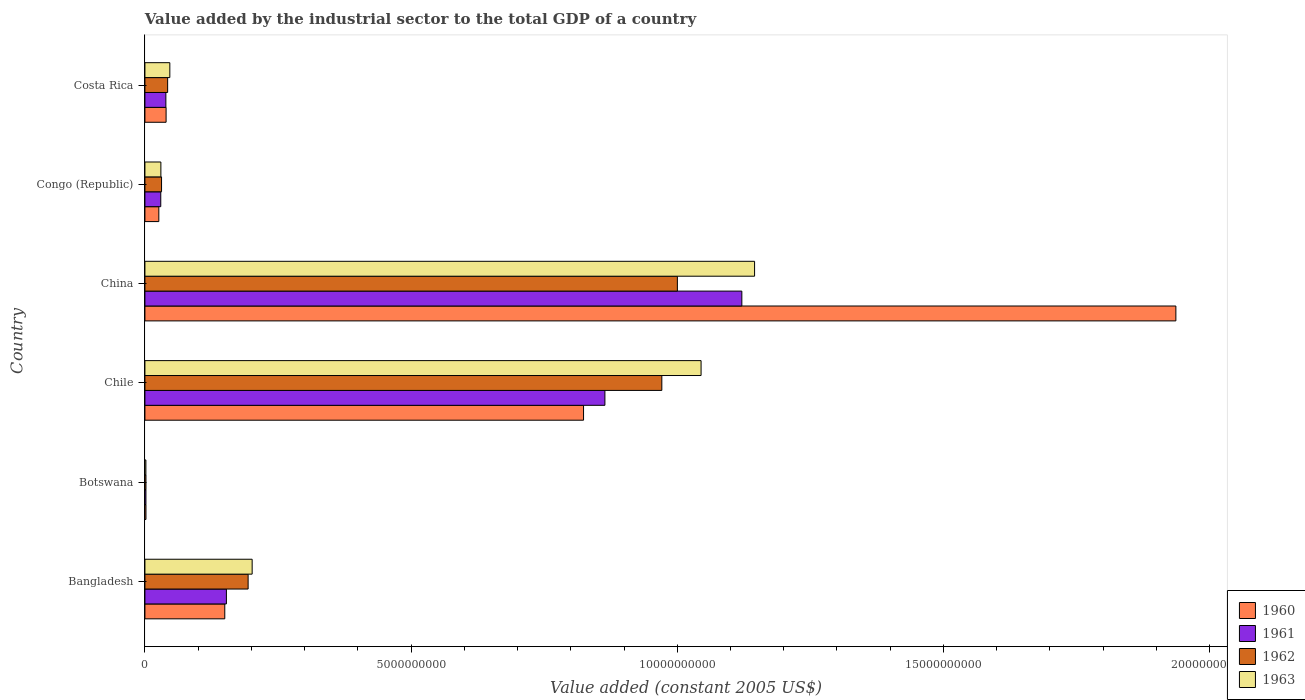Are the number of bars per tick equal to the number of legend labels?
Offer a terse response. Yes. What is the label of the 2nd group of bars from the top?
Your answer should be compact. Congo (Republic). In how many cases, is the number of bars for a given country not equal to the number of legend labels?
Ensure brevity in your answer.  0. What is the value added by the industrial sector in 1963 in Bangladesh?
Your answer should be very brief. 2.01e+09. Across all countries, what is the maximum value added by the industrial sector in 1963?
Offer a very short reply. 1.15e+1. Across all countries, what is the minimum value added by the industrial sector in 1960?
Offer a very short reply. 1.96e+07. In which country was the value added by the industrial sector in 1960 maximum?
Keep it short and to the point. China. In which country was the value added by the industrial sector in 1960 minimum?
Offer a terse response. Botswana. What is the total value added by the industrial sector in 1962 in the graph?
Your answer should be very brief. 2.24e+1. What is the difference between the value added by the industrial sector in 1963 in Botswana and that in Costa Rica?
Offer a terse response. -4.50e+08. What is the difference between the value added by the industrial sector in 1962 in Botswana and the value added by the industrial sector in 1963 in Congo (Republic)?
Your response must be concise. -2.80e+08. What is the average value added by the industrial sector in 1960 per country?
Offer a very short reply. 4.96e+09. What is the difference between the value added by the industrial sector in 1960 and value added by the industrial sector in 1961 in China?
Keep it short and to the point. 8.15e+09. In how many countries, is the value added by the industrial sector in 1961 greater than 3000000000 US$?
Ensure brevity in your answer.  2. What is the ratio of the value added by the industrial sector in 1960 in Bangladesh to that in Chile?
Provide a short and direct response. 0.18. Is the value added by the industrial sector in 1963 in Botswana less than that in Costa Rica?
Make the answer very short. Yes. What is the difference between the highest and the second highest value added by the industrial sector in 1960?
Provide a succinct answer. 1.11e+1. What is the difference between the highest and the lowest value added by the industrial sector in 1961?
Provide a short and direct response. 1.12e+1. Is the sum of the value added by the industrial sector in 1960 in China and Congo (Republic) greater than the maximum value added by the industrial sector in 1963 across all countries?
Offer a very short reply. Yes. How many bars are there?
Ensure brevity in your answer.  24. Are the values on the major ticks of X-axis written in scientific E-notation?
Offer a very short reply. No. Does the graph contain any zero values?
Keep it short and to the point. No. Does the graph contain grids?
Offer a terse response. No. Where does the legend appear in the graph?
Your answer should be very brief. Bottom right. How many legend labels are there?
Keep it short and to the point. 4. How are the legend labels stacked?
Provide a succinct answer. Vertical. What is the title of the graph?
Offer a very short reply. Value added by the industrial sector to the total GDP of a country. Does "1998" appear as one of the legend labels in the graph?
Make the answer very short. No. What is the label or title of the X-axis?
Make the answer very short. Value added (constant 2005 US$). What is the label or title of the Y-axis?
Your response must be concise. Country. What is the Value added (constant 2005 US$) of 1960 in Bangladesh?
Offer a terse response. 1.50e+09. What is the Value added (constant 2005 US$) of 1961 in Bangladesh?
Offer a very short reply. 1.53e+09. What is the Value added (constant 2005 US$) in 1962 in Bangladesh?
Keep it short and to the point. 1.94e+09. What is the Value added (constant 2005 US$) of 1963 in Bangladesh?
Ensure brevity in your answer.  2.01e+09. What is the Value added (constant 2005 US$) of 1960 in Botswana?
Make the answer very short. 1.96e+07. What is the Value added (constant 2005 US$) of 1961 in Botswana?
Your response must be concise. 1.92e+07. What is the Value added (constant 2005 US$) of 1962 in Botswana?
Provide a short and direct response. 1.98e+07. What is the Value added (constant 2005 US$) of 1963 in Botswana?
Make the answer very short. 1.83e+07. What is the Value added (constant 2005 US$) of 1960 in Chile?
Make the answer very short. 8.24e+09. What is the Value added (constant 2005 US$) in 1961 in Chile?
Your answer should be compact. 8.64e+09. What is the Value added (constant 2005 US$) in 1962 in Chile?
Your response must be concise. 9.71e+09. What is the Value added (constant 2005 US$) of 1963 in Chile?
Your answer should be compact. 1.04e+1. What is the Value added (constant 2005 US$) of 1960 in China?
Make the answer very short. 1.94e+1. What is the Value added (constant 2005 US$) of 1961 in China?
Your answer should be compact. 1.12e+1. What is the Value added (constant 2005 US$) of 1962 in China?
Provide a succinct answer. 1.00e+1. What is the Value added (constant 2005 US$) of 1963 in China?
Offer a very short reply. 1.15e+1. What is the Value added (constant 2005 US$) of 1960 in Congo (Republic)?
Ensure brevity in your answer.  2.61e+08. What is the Value added (constant 2005 US$) in 1961 in Congo (Republic)?
Give a very brief answer. 2.98e+08. What is the Value added (constant 2005 US$) in 1962 in Congo (Republic)?
Your answer should be compact. 3.12e+08. What is the Value added (constant 2005 US$) in 1963 in Congo (Republic)?
Give a very brief answer. 3.00e+08. What is the Value added (constant 2005 US$) of 1960 in Costa Rica?
Ensure brevity in your answer.  3.98e+08. What is the Value added (constant 2005 US$) in 1961 in Costa Rica?
Provide a succinct answer. 3.94e+08. What is the Value added (constant 2005 US$) of 1962 in Costa Rica?
Provide a short and direct response. 4.27e+08. What is the Value added (constant 2005 US$) of 1963 in Costa Rica?
Provide a succinct answer. 4.68e+08. Across all countries, what is the maximum Value added (constant 2005 US$) in 1960?
Provide a short and direct response. 1.94e+1. Across all countries, what is the maximum Value added (constant 2005 US$) in 1961?
Give a very brief answer. 1.12e+1. Across all countries, what is the maximum Value added (constant 2005 US$) in 1962?
Give a very brief answer. 1.00e+1. Across all countries, what is the maximum Value added (constant 2005 US$) of 1963?
Your response must be concise. 1.15e+1. Across all countries, what is the minimum Value added (constant 2005 US$) in 1960?
Provide a short and direct response. 1.96e+07. Across all countries, what is the minimum Value added (constant 2005 US$) in 1961?
Offer a very short reply. 1.92e+07. Across all countries, what is the minimum Value added (constant 2005 US$) in 1962?
Your answer should be very brief. 1.98e+07. Across all countries, what is the minimum Value added (constant 2005 US$) of 1963?
Ensure brevity in your answer.  1.83e+07. What is the total Value added (constant 2005 US$) of 1960 in the graph?
Your response must be concise. 2.98e+1. What is the total Value added (constant 2005 US$) of 1961 in the graph?
Your answer should be compact. 2.21e+1. What is the total Value added (constant 2005 US$) in 1962 in the graph?
Ensure brevity in your answer.  2.24e+1. What is the total Value added (constant 2005 US$) in 1963 in the graph?
Your answer should be compact. 2.47e+1. What is the difference between the Value added (constant 2005 US$) of 1960 in Bangladesh and that in Botswana?
Your response must be concise. 1.48e+09. What is the difference between the Value added (constant 2005 US$) in 1961 in Bangladesh and that in Botswana?
Make the answer very short. 1.51e+09. What is the difference between the Value added (constant 2005 US$) of 1962 in Bangladesh and that in Botswana?
Your answer should be compact. 1.92e+09. What is the difference between the Value added (constant 2005 US$) of 1963 in Bangladesh and that in Botswana?
Provide a succinct answer. 2.00e+09. What is the difference between the Value added (constant 2005 US$) of 1960 in Bangladesh and that in Chile?
Make the answer very short. -6.74e+09. What is the difference between the Value added (constant 2005 US$) in 1961 in Bangladesh and that in Chile?
Provide a short and direct response. -7.11e+09. What is the difference between the Value added (constant 2005 US$) in 1962 in Bangladesh and that in Chile?
Provide a short and direct response. -7.77e+09. What is the difference between the Value added (constant 2005 US$) in 1963 in Bangladesh and that in Chile?
Offer a very short reply. -8.43e+09. What is the difference between the Value added (constant 2005 US$) in 1960 in Bangladesh and that in China?
Your answer should be very brief. -1.79e+1. What is the difference between the Value added (constant 2005 US$) of 1961 in Bangladesh and that in China?
Your response must be concise. -9.68e+09. What is the difference between the Value added (constant 2005 US$) in 1962 in Bangladesh and that in China?
Offer a terse response. -8.06e+09. What is the difference between the Value added (constant 2005 US$) in 1963 in Bangladesh and that in China?
Your answer should be very brief. -9.44e+09. What is the difference between the Value added (constant 2005 US$) in 1960 in Bangladesh and that in Congo (Republic)?
Your answer should be compact. 1.24e+09. What is the difference between the Value added (constant 2005 US$) in 1961 in Bangladesh and that in Congo (Republic)?
Your answer should be very brief. 1.23e+09. What is the difference between the Value added (constant 2005 US$) in 1962 in Bangladesh and that in Congo (Republic)?
Your response must be concise. 1.63e+09. What is the difference between the Value added (constant 2005 US$) of 1963 in Bangladesh and that in Congo (Republic)?
Ensure brevity in your answer.  1.71e+09. What is the difference between the Value added (constant 2005 US$) in 1960 in Bangladesh and that in Costa Rica?
Make the answer very short. 1.10e+09. What is the difference between the Value added (constant 2005 US$) of 1961 in Bangladesh and that in Costa Rica?
Give a very brief answer. 1.14e+09. What is the difference between the Value added (constant 2005 US$) in 1962 in Bangladesh and that in Costa Rica?
Keep it short and to the point. 1.51e+09. What is the difference between the Value added (constant 2005 US$) of 1963 in Bangladesh and that in Costa Rica?
Offer a very short reply. 1.55e+09. What is the difference between the Value added (constant 2005 US$) of 1960 in Botswana and that in Chile?
Provide a short and direct response. -8.22e+09. What is the difference between the Value added (constant 2005 US$) in 1961 in Botswana and that in Chile?
Provide a short and direct response. -8.62e+09. What is the difference between the Value added (constant 2005 US$) in 1962 in Botswana and that in Chile?
Give a very brief answer. -9.69e+09. What is the difference between the Value added (constant 2005 US$) of 1963 in Botswana and that in Chile?
Keep it short and to the point. -1.04e+1. What is the difference between the Value added (constant 2005 US$) of 1960 in Botswana and that in China?
Your answer should be very brief. -1.93e+1. What is the difference between the Value added (constant 2005 US$) in 1961 in Botswana and that in China?
Your response must be concise. -1.12e+1. What is the difference between the Value added (constant 2005 US$) in 1962 in Botswana and that in China?
Your response must be concise. -9.98e+09. What is the difference between the Value added (constant 2005 US$) in 1963 in Botswana and that in China?
Your answer should be very brief. -1.14e+1. What is the difference between the Value added (constant 2005 US$) in 1960 in Botswana and that in Congo (Republic)?
Provide a succinct answer. -2.42e+08. What is the difference between the Value added (constant 2005 US$) of 1961 in Botswana and that in Congo (Republic)?
Provide a short and direct response. -2.78e+08. What is the difference between the Value added (constant 2005 US$) of 1962 in Botswana and that in Congo (Republic)?
Provide a short and direct response. -2.93e+08. What is the difference between the Value added (constant 2005 US$) in 1963 in Botswana and that in Congo (Republic)?
Offer a very short reply. -2.81e+08. What is the difference between the Value added (constant 2005 US$) in 1960 in Botswana and that in Costa Rica?
Provide a succinct answer. -3.78e+08. What is the difference between the Value added (constant 2005 US$) of 1961 in Botswana and that in Costa Rica?
Offer a terse response. -3.74e+08. What is the difference between the Value added (constant 2005 US$) in 1962 in Botswana and that in Costa Rica?
Make the answer very short. -4.07e+08. What is the difference between the Value added (constant 2005 US$) of 1963 in Botswana and that in Costa Rica?
Offer a terse response. -4.50e+08. What is the difference between the Value added (constant 2005 US$) in 1960 in Chile and that in China?
Give a very brief answer. -1.11e+1. What is the difference between the Value added (constant 2005 US$) in 1961 in Chile and that in China?
Keep it short and to the point. -2.57e+09. What is the difference between the Value added (constant 2005 US$) of 1962 in Chile and that in China?
Provide a short and direct response. -2.92e+08. What is the difference between the Value added (constant 2005 US$) of 1963 in Chile and that in China?
Keep it short and to the point. -1.01e+09. What is the difference between the Value added (constant 2005 US$) of 1960 in Chile and that in Congo (Republic)?
Provide a short and direct response. 7.98e+09. What is the difference between the Value added (constant 2005 US$) in 1961 in Chile and that in Congo (Republic)?
Make the answer very short. 8.34e+09. What is the difference between the Value added (constant 2005 US$) in 1962 in Chile and that in Congo (Republic)?
Offer a very short reply. 9.40e+09. What is the difference between the Value added (constant 2005 US$) in 1963 in Chile and that in Congo (Republic)?
Provide a short and direct response. 1.01e+1. What is the difference between the Value added (constant 2005 US$) in 1960 in Chile and that in Costa Rica?
Provide a short and direct response. 7.84e+09. What is the difference between the Value added (constant 2005 US$) in 1961 in Chile and that in Costa Rica?
Offer a terse response. 8.25e+09. What is the difference between the Value added (constant 2005 US$) of 1962 in Chile and that in Costa Rica?
Your answer should be very brief. 9.28e+09. What is the difference between the Value added (constant 2005 US$) in 1963 in Chile and that in Costa Rica?
Your answer should be compact. 9.98e+09. What is the difference between the Value added (constant 2005 US$) in 1960 in China and that in Congo (Republic)?
Your answer should be compact. 1.91e+1. What is the difference between the Value added (constant 2005 US$) in 1961 in China and that in Congo (Republic)?
Your answer should be compact. 1.09e+1. What is the difference between the Value added (constant 2005 US$) in 1962 in China and that in Congo (Republic)?
Offer a terse response. 9.69e+09. What is the difference between the Value added (constant 2005 US$) of 1963 in China and that in Congo (Republic)?
Offer a very short reply. 1.12e+1. What is the difference between the Value added (constant 2005 US$) of 1960 in China and that in Costa Rica?
Offer a very short reply. 1.90e+1. What is the difference between the Value added (constant 2005 US$) of 1961 in China and that in Costa Rica?
Your answer should be compact. 1.08e+1. What is the difference between the Value added (constant 2005 US$) of 1962 in China and that in Costa Rica?
Your answer should be very brief. 9.58e+09. What is the difference between the Value added (constant 2005 US$) in 1963 in China and that in Costa Rica?
Your answer should be very brief. 1.10e+1. What is the difference between the Value added (constant 2005 US$) of 1960 in Congo (Republic) and that in Costa Rica?
Make the answer very short. -1.36e+08. What is the difference between the Value added (constant 2005 US$) of 1961 in Congo (Republic) and that in Costa Rica?
Your answer should be very brief. -9.59e+07. What is the difference between the Value added (constant 2005 US$) of 1962 in Congo (Republic) and that in Costa Rica?
Provide a succinct answer. -1.14e+08. What is the difference between the Value added (constant 2005 US$) of 1963 in Congo (Republic) and that in Costa Rica?
Make the answer very short. -1.68e+08. What is the difference between the Value added (constant 2005 US$) in 1960 in Bangladesh and the Value added (constant 2005 US$) in 1961 in Botswana?
Give a very brief answer. 1.48e+09. What is the difference between the Value added (constant 2005 US$) in 1960 in Bangladesh and the Value added (constant 2005 US$) in 1962 in Botswana?
Your answer should be very brief. 1.48e+09. What is the difference between the Value added (constant 2005 US$) of 1960 in Bangladesh and the Value added (constant 2005 US$) of 1963 in Botswana?
Your answer should be very brief. 1.48e+09. What is the difference between the Value added (constant 2005 US$) of 1961 in Bangladesh and the Value added (constant 2005 US$) of 1962 in Botswana?
Ensure brevity in your answer.  1.51e+09. What is the difference between the Value added (constant 2005 US$) of 1961 in Bangladesh and the Value added (constant 2005 US$) of 1963 in Botswana?
Provide a succinct answer. 1.51e+09. What is the difference between the Value added (constant 2005 US$) in 1962 in Bangladesh and the Value added (constant 2005 US$) in 1963 in Botswana?
Offer a terse response. 1.92e+09. What is the difference between the Value added (constant 2005 US$) in 1960 in Bangladesh and the Value added (constant 2005 US$) in 1961 in Chile?
Offer a very short reply. -7.14e+09. What is the difference between the Value added (constant 2005 US$) of 1960 in Bangladesh and the Value added (constant 2005 US$) of 1962 in Chile?
Offer a very short reply. -8.21e+09. What is the difference between the Value added (constant 2005 US$) in 1960 in Bangladesh and the Value added (constant 2005 US$) in 1963 in Chile?
Keep it short and to the point. -8.95e+09. What is the difference between the Value added (constant 2005 US$) in 1961 in Bangladesh and the Value added (constant 2005 US$) in 1962 in Chile?
Give a very brief answer. -8.18e+09. What is the difference between the Value added (constant 2005 US$) of 1961 in Bangladesh and the Value added (constant 2005 US$) of 1963 in Chile?
Ensure brevity in your answer.  -8.92e+09. What is the difference between the Value added (constant 2005 US$) in 1962 in Bangladesh and the Value added (constant 2005 US$) in 1963 in Chile?
Give a very brief answer. -8.51e+09. What is the difference between the Value added (constant 2005 US$) in 1960 in Bangladesh and the Value added (constant 2005 US$) in 1961 in China?
Provide a short and direct response. -9.71e+09. What is the difference between the Value added (constant 2005 US$) in 1960 in Bangladesh and the Value added (constant 2005 US$) in 1962 in China?
Your answer should be compact. -8.50e+09. What is the difference between the Value added (constant 2005 US$) in 1960 in Bangladesh and the Value added (constant 2005 US$) in 1963 in China?
Your answer should be very brief. -9.95e+09. What is the difference between the Value added (constant 2005 US$) of 1961 in Bangladesh and the Value added (constant 2005 US$) of 1962 in China?
Your answer should be very brief. -8.47e+09. What is the difference between the Value added (constant 2005 US$) in 1961 in Bangladesh and the Value added (constant 2005 US$) in 1963 in China?
Your response must be concise. -9.92e+09. What is the difference between the Value added (constant 2005 US$) in 1962 in Bangladesh and the Value added (constant 2005 US$) in 1963 in China?
Provide a succinct answer. -9.51e+09. What is the difference between the Value added (constant 2005 US$) in 1960 in Bangladesh and the Value added (constant 2005 US$) in 1961 in Congo (Republic)?
Keep it short and to the point. 1.20e+09. What is the difference between the Value added (constant 2005 US$) of 1960 in Bangladesh and the Value added (constant 2005 US$) of 1962 in Congo (Republic)?
Your answer should be very brief. 1.19e+09. What is the difference between the Value added (constant 2005 US$) in 1960 in Bangladesh and the Value added (constant 2005 US$) in 1963 in Congo (Republic)?
Give a very brief answer. 1.20e+09. What is the difference between the Value added (constant 2005 US$) of 1961 in Bangladesh and the Value added (constant 2005 US$) of 1962 in Congo (Republic)?
Give a very brief answer. 1.22e+09. What is the difference between the Value added (constant 2005 US$) in 1961 in Bangladesh and the Value added (constant 2005 US$) in 1963 in Congo (Republic)?
Provide a succinct answer. 1.23e+09. What is the difference between the Value added (constant 2005 US$) of 1962 in Bangladesh and the Value added (constant 2005 US$) of 1963 in Congo (Republic)?
Provide a short and direct response. 1.64e+09. What is the difference between the Value added (constant 2005 US$) in 1960 in Bangladesh and the Value added (constant 2005 US$) in 1961 in Costa Rica?
Keep it short and to the point. 1.11e+09. What is the difference between the Value added (constant 2005 US$) of 1960 in Bangladesh and the Value added (constant 2005 US$) of 1962 in Costa Rica?
Offer a terse response. 1.07e+09. What is the difference between the Value added (constant 2005 US$) in 1960 in Bangladesh and the Value added (constant 2005 US$) in 1963 in Costa Rica?
Your answer should be very brief. 1.03e+09. What is the difference between the Value added (constant 2005 US$) in 1961 in Bangladesh and the Value added (constant 2005 US$) in 1962 in Costa Rica?
Make the answer very short. 1.10e+09. What is the difference between the Value added (constant 2005 US$) of 1961 in Bangladesh and the Value added (constant 2005 US$) of 1963 in Costa Rica?
Provide a succinct answer. 1.06e+09. What is the difference between the Value added (constant 2005 US$) in 1962 in Bangladesh and the Value added (constant 2005 US$) in 1963 in Costa Rica?
Provide a short and direct response. 1.47e+09. What is the difference between the Value added (constant 2005 US$) in 1960 in Botswana and the Value added (constant 2005 US$) in 1961 in Chile?
Ensure brevity in your answer.  -8.62e+09. What is the difference between the Value added (constant 2005 US$) in 1960 in Botswana and the Value added (constant 2005 US$) in 1962 in Chile?
Your answer should be very brief. -9.69e+09. What is the difference between the Value added (constant 2005 US$) in 1960 in Botswana and the Value added (constant 2005 US$) in 1963 in Chile?
Your response must be concise. -1.04e+1. What is the difference between the Value added (constant 2005 US$) in 1961 in Botswana and the Value added (constant 2005 US$) in 1962 in Chile?
Give a very brief answer. -9.69e+09. What is the difference between the Value added (constant 2005 US$) in 1961 in Botswana and the Value added (constant 2005 US$) in 1963 in Chile?
Your answer should be very brief. -1.04e+1. What is the difference between the Value added (constant 2005 US$) of 1962 in Botswana and the Value added (constant 2005 US$) of 1963 in Chile?
Ensure brevity in your answer.  -1.04e+1. What is the difference between the Value added (constant 2005 US$) in 1960 in Botswana and the Value added (constant 2005 US$) in 1961 in China?
Your answer should be very brief. -1.12e+1. What is the difference between the Value added (constant 2005 US$) of 1960 in Botswana and the Value added (constant 2005 US$) of 1962 in China?
Offer a very short reply. -9.98e+09. What is the difference between the Value added (constant 2005 US$) in 1960 in Botswana and the Value added (constant 2005 US$) in 1963 in China?
Keep it short and to the point. -1.14e+1. What is the difference between the Value added (constant 2005 US$) of 1961 in Botswana and the Value added (constant 2005 US$) of 1962 in China?
Provide a succinct answer. -9.98e+09. What is the difference between the Value added (constant 2005 US$) of 1961 in Botswana and the Value added (constant 2005 US$) of 1963 in China?
Your answer should be compact. -1.14e+1. What is the difference between the Value added (constant 2005 US$) in 1962 in Botswana and the Value added (constant 2005 US$) in 1963 in China?
Provide a succinct answer. -1.14e+1. What is the difference between the Value added (constant 2005 US$) in 1960 in Botswana and the Value added (constant 2005 US$) in 1961 in Congo (Republic)?
Offer a very short reply. -2.78e+08. What is the difference between the Value added (constant 2005 US$) in 1960 in Botswana and the Value added (constant 2005 US$) in 1962 in Congo (Republic)?
Your answer should be compact. -2.93e+08. What is the difference between the Value added (constant 2005 US$) of 1960 in Botswana and the Value added (constant 2005 US$) of 1963 in Congo (Republic)?
Offer a very short reply. -2.80e+08. What is the difference between the Value added (constant 2005 US$) in 1961 in Botswana and the Value added (constant 2005 US$) in 1962 in Congo (Republic)?
Make the answer very short. -2.93e+08. What is the difference between the Value added (constant 2005 US$) of 1961 in Botswana and the Value added (constant 2005 US$) of 1963 in Congo (Republic)?
Your response must be concise. -2.81e+08. What is the difference between the Value added (constant 2005 US$) in 1962 in Botswana and the Value added (constant 2005 US$) in 1963 in Congo (Republic)?
Your answer should be compact. -2.80e+08. What is the difference between the Value added (constant 2005 US$) of 1960 in Botswana and the Value added (constant 2005 US$) of 1961 in Costa Rica?
Make the answer very short. -3.74e+08. What is the difference between the Value added (constant 2005 US$) in 1960 in Botswana and the Value added (constant 2005 US$) in 1962 in Costa Rica?
Make the answer very short. -4.07e+08. What is the difference between the Value added (constant 2005 US$) in 1960 in Botswana and the Value added (constant 2005 US$) in 1963 in Costa Rica?
Provide a succinct answer. -4.48e+08. What is the difference between the Value added (constant 2005 US$) in 1961 in Botswana and the Value added (constant 2005 US$) in 1962 in Costa Rica?
Your answer should be very brief. -4.08e+08. What is the difference between the Value added (constant 2005 US$) of 1961 in Botswana and the Value added (constant 2005 US$) of 1963 in Costa Rica?
Offer a terse response. -4.49e+08. What is the difference between the Value added (constant 2005 US$) in 1962 in Botswana and the Value added (constant 2005 US$) in 1963 in Costa Rica?
Offer a terse response. -4.48e+08. What is the difference between the Value added (constant 2005 US$) of 1960 in Chile and the Value added (constant 2005 US$) of 1961 in China?
Keep it short and to the point. -2.97e+09. What is the difference between the Value added (constant 2005 US$) in 1960 in Chile and the Value added (constant 2005 US$) in 1962 in China?
Make the answer very short. -1.76e+09. What is the difference between the Value added (constant 2005 US$) in 1960 in Chile and the Value added (constant 2005 US$) in 1963 in China?
Offer a terse response. -3.21e+09. What is the difference between the Value added (constant 2005 US$) in 1961 in Chile and the Value added (constant 2005 US$) in 1962 in China?
Provide a succinct answer. -1.36e+09. What is the difference between the Value added (constant 2005 US$) of 1961 in Chile and the Value added (constant 2005 US$) of 1963 in China?
Your answer should be compact. -2.81e+09. What is the difference between the Value added (constant 2005 US$) in 1962 in Chile and the Value added (constant 2005 US$) in 1963 in China?
Your response must be concise. -1.74e+09. What is the difference between the Value added (constant 2005 US$) of 1960 in Chile and the Value added (constant 2005 US$) of 1961 in Congo (Republic)?
Give a very brief answer. 7.94e+09. What is the difference between the Value added (constant 2005 US$) in 1960 in Chile and the Value added (constant 2005 US$) in 1962 in Congo (Republic)?
Your response must be concise. 7.93e+09. What is the difference between the Value added (constant 2005 US$) of 1960 in Chile and the Value added (constant 2005 US$) of 1963 in Congo (Republic)?
Offer a very short reply. 7.94e+09. What is the difference between the Value added (constant 2005 US$) in 1961 in Chile and the Value added (constant 2005 US$) in 1962 in Congo (Republic)?
Provide a succinct answer. 8.33e+09. What is the difference between the Value added (constant 2005 US$) of 1961 in Chile and the Value added (constant 2005 US$) of 1963 in Congo (Republic)?
Make the answer very short. 8.34e+09. What is the difference between the Value added (constant 2005 US$) in 1962 in Chile and the Value added (constant 2005 US$) in 1963 in Congo (Republic)?
Keep it short and to the point. 9.41e+09. What is the difference between the Value added (constant 2005 US$) in 1960 in Chile and the Value added (constant 2005 US$) in 1961 in Costa Rica?
Keep it short and to the point. 7.85e+09. What is the difference between the Value added (constant 2005 US$) of 1960 in Chile and the Value added (constant 2005 US$) of 1962 in Costa Rica?
Give a very brief answer. 7.81e+09. What is the difference between the Value added (constant 2005 US$) in 1960 in Chile and the Value added (constant 2005 US$) in 1963 in Costa Rica?
Offer a very short reply. 7.77e+09. What is the difference between the Value added (constant 2005 US$) in 1961 in Chile and the Value added (constant 2005 US$) in 1962 in Costa Rica?
Offer a terse response. 8.21e+09. What is the difference between the Value added (constant 2005 US$) of 1961 in Chile and the Value added (constant 2005 US$) of 1963 in Costa Rica?
Your response must be concise. 8.17e+09. What is the difference between the Value added (constant 2005 US$) in 1962 in Chile and the Value added (constant 2005 US$) in 1963 in Costa Rica?
Ensure brevity in your answer.  9.24e+09. What is the difference between the Value added (constant 2005 US$) in 1960 in China and the Value added (constant 2005 US$) in 1961 in Congo (Republic)?
Offer a terse response. 1.91e+1. What is the difference between the Value added (constant 2005 US$) of 1960 in China and the Value added (constant 2005 US$) of 1962 in Congo (Republic)?
Provide a succinct answer. 1.91e+1. What is the difference between the Value added (constant 2005 US$) in 1960 in China and the Value added (constant 2005 US$) in 1963 in Congo (Republic)?
Offer a very short reply. 1.91e+1. What is the difference between the Value added (constant 2005 US$) in 1961 in China and the Value added (constant 2005 US$) in 1962 in Congo (Republic)?
Your answer should be compact. 1.09e+1. What is the difference between the Value added (constant 2005 US$) of 1961 in China and the Value added (constant 2005 US$) of 1963 in Congo (Republic)?
Your response must be concise. 1.09e+1. What is the difference between the Value added (constant 2005 US$) of 1962 in China and the Value added (constant 2005 US$) of 1963 in Congo (Republic)?
Offer a terse response. 9.70e+09. What is the difference between the Value added (constant 2005 US$) of 1960 in China and the Value added (constant 2005 US$) of 1961 in Costa Rica?
Your answer should be compact. 1.90e+1. What is the difference between the Value added (constant 2005 US$) in 1960 in China and the Value added (constant 2005 US$) in 1962 in Costa Rica?
Your answer should be compact. 1.89e+1. What is the difference between the Value added (constant 2005 US$) in 1960 in China and the Value added (constant 2005 US$) in 1963 in Costa Rica?
Keep it short and to the point. 1.89e+1. What is the difference between the Value added (constant 2005 US$) of 1961 in China and the Value added (constant 2005 US$) of 1962 in Costa Rica?
Offer a very short reply. 1.08e+1. What is the difference between the Value added (constant 2005 US$) of 1961 in China and the Value added (constant 2005 US$) of 1963 in Costa Rica?
Keep it short and to the point. 1.07e+1. What is the difference between the Value added (constant 2005 US$) of 1962 in China and the Value added (constant 2005 US$) of 1963 in Costa Rica?
Provide a succinct answer. 9.53e+09. What is the difference between the Value added (constant 2005 US$) in 1960 in Congo (Republic) and the Value added (constant 2005 US$) in 1961 in Costa Rica?
Offer a very short reply. -1.32e+08. What is the difference between the Value added (constant 2005 US$) of 1960 in Congo (Republic) and the Value added (constant 2005 US$) of 1962 in Costa Rica?
Your answer should be compact. -1.65e+08. What is the difference between the Value added (constant 2005 US$) in 1960 in Congo (Republic) and the Value added (constant 2005 US$) in 1963 in Costa Rica?
Offer a very short reply. -2.07e+08. What is the difference between the Value added (constant 2005 US$) of 1961 in Congo (Republic) and the Value added (constant 2005 US$) of 1962 in Costa Rica?
Your answer should be compact. -1.29e+08. What is the difference between the Value added (constant 2005 US$) in 1961 in Congo (Republic) and the Value added (constant 2005 US$) in 1963 in Costa Rica?
Offer a terse response. -1.70e+08. What is the difference between the Value added (constant 2005 US$) in 1962 in Congo (Republic) and the Value added (constant 2005 US$) in 1963 in Costa Rica?
Your answer should be compact. -1.56e+08. What is the average Value added (constant 2005 US$) of 1960 per country?
Offer a very short reply. 4.96e+09. What is the average Value added (constant 2005 US$) of 1961 per country?
Keep it short and to the point. 3.68e+09. What is the average Value added (constant 2005 US$) in 1962 per country?
Give a very brief answer. 3.74e+09. What is the average Value added (constant 2005 US$) in 1963 per country?
Provide a short and direct response. 4.12e+09. What is the difference between the Value added (constant 2005 US$) of 1960 and Value added (constant 2005 US$) of 1961 in Bangladesh?
Give a very brief answer. -3.05e+07. What is the difference between the Value added (constant 2005 US$) of 1960 and Value added (constant 2005 US$) of 1962 in Bangladesh?
Your answer should be compact. -4.38e+08. What is the difference between the Value added (constant 2005 US$) in 1960 and Value added (constant 2005 US$) in 1963 in Bangladesh?
Offer a terse response. -5.14e+08. What is the difference between the Value added (constant 2005 US$) in 1961 and Value added (constant 2005 US$) in 1962 in Bangladesh?
Your answer should be very brief. -4.08e+08. What is the difference between the Value added (constant 2005 US$) of 1961 and Value added (constant 2005 US$) of 1963 in Bangladesh?
Make the answer very short. -4.84e+08. What is the difference between the Value added (constant 2005 US$) in 1962 and Value added (constant 2005 US$) in 1963 in Bangladesh?
Make the answer very short. -7.60e+07. What is the difference between the Value added (constant 2005 US$) in 1960 and Value added (constant 2005 US$) in 1961 in Botswana?
Keep it short and to the point. 4.24e+05. What is the difference between the Value added (constant 2005 US$) of 1960 and Value added (constant 2005 US$) of 1962 in Botswana?
Provide a short and direct response. -2.12e+05. What is the difference between the Value added (constant 2005 US$) of 1960 and Value added (constant 2005 US$) of 1963 in Botswana?
Give a very brief answer. 1.27e+06. What is the difference between the Value added (constant 2005 US$) in 1961 and Value added (constant 2005 US$) in 1962 in Botswana?
Your answer should be very brief. -6.36e+05. What is the difference between the Value added (constant 2005 US$) of 1961 and Value added (constant 2005 US$) of 1963 in Botswana?
Give a very brief answer. 8.48e+05. What is the difference between the Value added (constant 2005 US$) in 1962 and Value added (constant 2005 US$) in 1963 in Botswana?
Your response must be concise. 1.48e+06. What is the difference between the Value added (constant 2005 US$) in 1960 and Value added (constant 2005 US$) in 1961 in Chile?
Your response must be concise. -4.01e+08. What is the difference between the Value added (constant 2005 US$) of 1960 and Value added (constant 2005 US$) of 1962 in Chile?
Make the answer very short. -1.47e+09. What is the difference between the Value added (constant 2005 US$) in 1960 and Value added (constant 2005 US$) in 1963 in Chile?
Give a very brief answer. -2.21e+09. What is the difference between the Value added (constant 2005 US$) of 1961 and Value added (constant 2005 US$) of 1962 in Chile?
Your answer should be compact. -1.07e+09. What is the difference between the Value added (constant 2005 US$) in 1961 and Value added (constant 2005 US$) in 1963 in Chile?
Keep it short and to the point. -1.81e+09. What is the difference between the Value added (constant 2005 US$) of 1962 and Value added (constant 2005 US$) of 1963 in Chile?
Provide a short and direct response. -7.37e+08. What is the difference between the Value added (constant 2005 US$) in 1960 and Value added (constant 2005 US$) in 1961 in China?
Offer a terse response. 8.15e+09. What is the difference between the Value added (constant 2005 US$) in 1960 and Value added (constant 2005 US$) in 1962 in China?
Your answer should be compact. 9.36e+09. What is the difference between the Value added (constant 2005 US$) of 1960 and Value added (constant 2005 US$) of 1963 in China?
Make the answer very short. 7.91e+09. What is the difference between the Value added (constant 2005 US$) of 1961 and Value added (constant 2005 US$) of 1962 in China?
Keep it short and to the point. 1.21e+09. What is the difference between the Value added (constant 2005 US$) in 1961 and Value added (constant 2005 US$) in 1963 in China?
Your response must be concise. -2.39e+08. What is the difference between the Value added (constant 2005 US$) of 1962 and Value added (constant 2005 US$) of 1963 in China?
Provide a short and direct response. -1.45e+09. What is the difference between the Value added (constant 2005 US$) of 1960 and Value added (constant 2005 US$) of 1961 in Congo (Republic)?
Your answer should be very brief. -3.63e+07. What is the difference between the Value added (constant 2005 US$) of 1960 and Value added (constant 2005 US$) of 1962 in Congo (Republic)?
Ensure brevity in your answer.  -5.10e+07. What is the difference between the Value added (constant 2005 US$) in 1960 and Value added (constant 2005 US$) in 1963 in Congo (Republic)?
Your answer should be compact. -3.84e+07. What is the difference between the Value added (constant 2005 US$) in 1961 and Value added (constant 2005 US$) in 1962 in Congo (Republic)?
Offer a terse response. -1.47e+07. What is the difference between the Value added (constant 2005 US$) in 1961 and Value added (constant 2005 US$) in 1963 in Congo (Republic)?
Provide a succinct answer. -2.10e+06. What is the difference between the Value added (constant 2005 US$) of 1962 and Value added (constant 2005 US$) of 1963 in Congo (Republic)?
Offer a very short reply. 1.26e+07. What is the difference between the Value added (constant 2005 US$) of 1960 and Value added (constant 2005 US$) of 1961 in Costa Rica?
Provide a succinct answer. 4.19e+06. What is the difference between the Value added (constant 2005 US$) in 1960 and Value added (constant 2005 US$) in 1962 in Costa Rica?
Keep it short and to the point. -2.91e+07. What is the difference between the Value added (constant 2005 US$) in 1960 and Value added (constant 2005 US$) in 1963 in Costa Rica?
Your answer should be compact. -7.01e+07. What is the difference between the Value added (constant 2005 US$) in 1961 and Value added (constant 2005 US$) in 1962 in Costa Rica?
Ensure brevity in your answer.  -3.32e+07. What is the difference between the Value added (constant 2005 US$) of 1961 and Value added (constant 2005 US$) of 1963 in Costa Rica?
Keep it short and to the point. -7.43e+07. What is the difference between the Value added (constant 2005 US$) of 1962 and Value added (constant 2005 US$) of 1963 in Costa Rica?
Your answer should be very brief. -4.11e+07. What is the ratio of the Value added (constant 2005 US$) in 1960 in Bangladesh to that in Botswana?
Your answer should be very brief. 76.48. What is the ratio of the Value added (constant 2005 US$) of 1961 in Bangladesh to that in Botswana?
Your answer should be compact. 79.76. What is the ratio of the Value added (constant 2005 US$) of 1962 in Bangladesh to that in Botswana?
Keep it short and to the point. 97.78. What is the ratio of the Value added (constant 2005 US$) of 1963 in Bangladesh to that in Botswana?
Offer a terse response. 109.83. What is the ratio of the Value added (constant 2005 US$) in 1960 in Bangladesh to that in Chile?
Give a very brief answer. 0.18. What is the ratio of the Value added (constant 2005 US$) in 1961 in Bangladesh to that in Chile?
Make the answer very short. 0.18. What is the ratio of the Value added (constant 2005 US$) in 1962 in Bangladesh to that in Chile?
Offer a terse response. 0.2. What is the ratio of the Value added (constant 2005 US$) in 1963 in Bangladesh to that in Chile?
Make the answer very short. 0.19. What is the ratio of the Value added (constant 2005 US$) in 1960 in Bangladesh to that in China?
Your response must be concise. 0.08. What is the ratio of the Value added (constant 2005 US$) of 1961 in Bangladesh to that in China?
Your answer should be compact. 0.14. What is the ratio of the Value added (constant 2005 US$) of 1962 in Bangladesh to that in China?
Provide a short and direct response. 0.19. What is the ratio of the Value added (constant 2005 US$) in 1963 in Bangladesh to that in China?
Your answer should be compact. 0.18. What is the ratio of the Value added (constant 2005 US$) in 1960 in Bangladesh to that in Congo (Republic)?
Offer a very short reply. 5.74. What is the ratio of the Value added (constant 2005 US$) of 1961 in Bangladesh to that in Congo (Republic)?
Ensure brevity in your answer.  5.14. What is the ratio of the Value added (constant 2005 US$) of 1962 in Bangladesh to that in Congo (Republic)?
Provide a succinct answer. 6.21. What is the ratio of the Value added (constant 2005 US$) in 1963 in Bangladesh to that in Congo (Republic)?
Ensure brevity in your answer.  6.72. What is the ratio of the Value added (constant 2005 US$) in 1960 in Bangladesh to that in Costa Rica?
Provide a short and direct response. 3.77. What is the ratio of the Value added (constant 2005 US$) in 1961 in Bangladesh to that in Costa Rica?
Offer a terse response. 3.89. What is the ratio of the Value added (constant 2005 US$) of 1962 in Bangladesh to that in Costa Rica?
Provide a succinct answer. 4.54. What is the ratio of the Value added (constant 2005 US$) of 1963 in Bangladesh to that in Costa Rica?
Ensure brevity in your answer.  4.31. What is the ratio of the Value added (constant 2005 US$) of 1960 in Botswana to that in Chile?
Keep it short and to the point. 0. What is the ratio of the Value added (constant 2005 US$) in 1961 in Botswana to that in Chile?
Offer a terse response. 0. What is the ratio of the Value added (constant 2005 US$) of 1962 in Botswana to that in Chile?
Offer a very short reply. 0. What is the ratio of the Value added (constant 2005 US$) of 1963 in Botswana to that in Chile?
Keep it short and to the point. 0. What is the ratio of the Value added (constant 2005 US$) in 1961 in Botswana to that in China?
Make the answer very short. 0. What is the ratio of the Value added (constant 2005 US$) of 1962 in Botswana to that in China?
Provide a succinct answer. 0. What is the ratio of the Value added (constant 2005 US$) in 1963 in Botswana to that in China?
Your response must be concise. 0. What is the ratio of the Value added (constant 2005 US$) in 1960 in Botswana to that in Congo (Republic)?
Your response must be concise. 0.07. What is the ratio of the Value added (constant 2005 US$) of 1961 in Botswana to that in Congo (Republic)?
Ensure brevity in your answer.  0.06. What is the ratio of the Value added (constant 2005 US$) of 1962 in Botswana to that in Congo (Republic)?
Your answer should be compact. 0.06. What is the ratio of the Value added (constant 2005 US$) of 1963 in Botswana to that in Congo (Republic)?
Offer a terse response. 0.06. What is the ratio of the Value added (constant 2005 US$) of 1960 in Botswana to that in Costa Rica?
Give a very brief answer. 0.05. What is the ratio of the Value added (constant 2005 US$) of 1961 in Botswana to that in Costa Rica?
Your answer should be compact. 0.05. What is the ratio of the Value added (constant 2005 US$) of 1962 in Botswana to that in Costa Rica?
Your answer should be very brief. 0.05. What is the ratio of the Value added (constant 2005 US$) in 1963 in Botswana to that in Costa Rica?
Keep it short and to the point. 0.04. What is the ratio of the Value added (constant 2005 US$) in 1960 in Chile to that in China?
Make the answer very short. 0.43. What is the ratio of the Value added (constant 2005 US$) in 1961 in Chile to that in China?
Provide a succinct answer. 0.77. What is the ratio of the Value added (constant 2005 US$) of 1962 in Chile to that in China?
Offer a very short reply. 0.97. What is the ratio of the Value added (constant 2005 US$) in 1963 in Chile to that in China?
Provide a succinct answer. 0.91. What is the ratio of the Value added (constant 2005 US$) of 1960 in Chile to that in Congo (Republic)?
Offer a terse response. 31.52. What is the ratio of the Value added (constant 2005 US$) of 1961 in Chile to that in Congo (Republic)?
Ensure brevity in your answer.  29.03. What is the ratio of the Value added (constant 2005 US$) in 1962 in Chile to that in Congo (Republic)?
Provide a succinct answer. 31.09. What is the ratio of the Value added (constant 2005 US$) of 1963 in Chile to that in Congo (Republic)?
Your answer should be very brief. 34.85. What is the ratio of the Value added (constant 2005 US$) in 1960 in Chile to that in Costa Rica?
Provide a succinct answer. 20.71. What is the ratio of the Value added (constant 2005 US$) in 1961 in Chile to that in Costa Rica?
Your answer should be compact. 21.95. What is the ratio of the Value added (constant 2005 US$) in 1962 in Chile to that in Costa Rica?
Give a very brief answer. 22.75. What is the ratio of the Value added (constant 2005 US$) of 1963 in Chile to that in Costa Rica?
Offer a very short reply. 22.33. What is the ratio of the Value added (constant 2005 US$) of 1960 in China to that in Congo (Republic)?
Make the answer very short. 74.09. What is the ratio of the Value added (constant 2005 US$) of 1961 in China to that in Congo (Republic)?
Offer a terse response. 37.67. What is the ratio of the Value added (constant 2005 US$) in 1962 in China to that in Congo (Republic)?
Provide a short and direct response. 32.02. What is the ratio of the Value added (constant 2005 US$) in 1963 in China to that in Congo (Republic)?
Offer a very short reply. 38.21. What is the ratio of the Value added (constant 2005 US$) in 1960 in China to that in Costa Rica?
Ensure brevity in your answer.  48.69. What is the ratio of the Value added (constant 2005 US$) in 1961 in China to that in Costa Rica?
Offer a terse response. 28.49. What is the ratio of the Value added (constant 2005 US$) of 1962 in China to that in Costa Rica?
Ensure brevity in your answer.  23.43. What is the ratio of the Value added (constant 2005 US$) of 1963 in China to that in Costa Rica?
Provide a succinct answer. 24.48. What is the ratio of the Value added (constant 2005 US$) of 1960 in Congo (Republic) to that in Costa Rica?
Offer a terse response. 0.66. What is the ratio of the Value added (constant 2005 US$) in 1961 in Congo (Republic) to that in Costa Rica?
Your answer should be very brief. 0.76. What is the ratio of the Value added (constant 2005 US$) of 1962 in Congo (Republic) to that in Costa Rica?
Give a very brief answer. 0.73. What is the ratio of the Value added (constant 2005 US$) of 1963 in Congo (Republic) to that in Costa Rica?
Make the answer very short. 0.64. What is the difference between the highest and the second highest Value added (constant 2005 US$) of 1960?
Offer a very short reply. 1.11e+1. What is the difference between the highest and the second highest Value added (constant 2005 US$) in 1961?
Your response must be concise. 2.57e+09. What is the difference between the highest and the second highest Value added (constant 2005 US$) in 1962?
Keep it short and to the point. 2.92e+08. What is the difference between the highest and the second highest Value added (constant 2005 US$) in 1963?
Offer a terse response. 1.01e+09. What is the difference between the highest and the lowest Value added (constant 2005 US$) in 1960?
Your response must be concise. 1.93e+1. What is the difference between the highest and the lowest Value added (constant 2005 US$) of 1961?
Keep it short and to the point. 1.12e+1. What is the difference between the highest and the lowest Value added (constant 2005 US$) in 1962?
Ensure brevity in your answer.  9.98e+09. What is the difference between the highest and the lowest Value added (constant 2005 US$) of 1963?
Offer a terse response. 1.14e+1. 